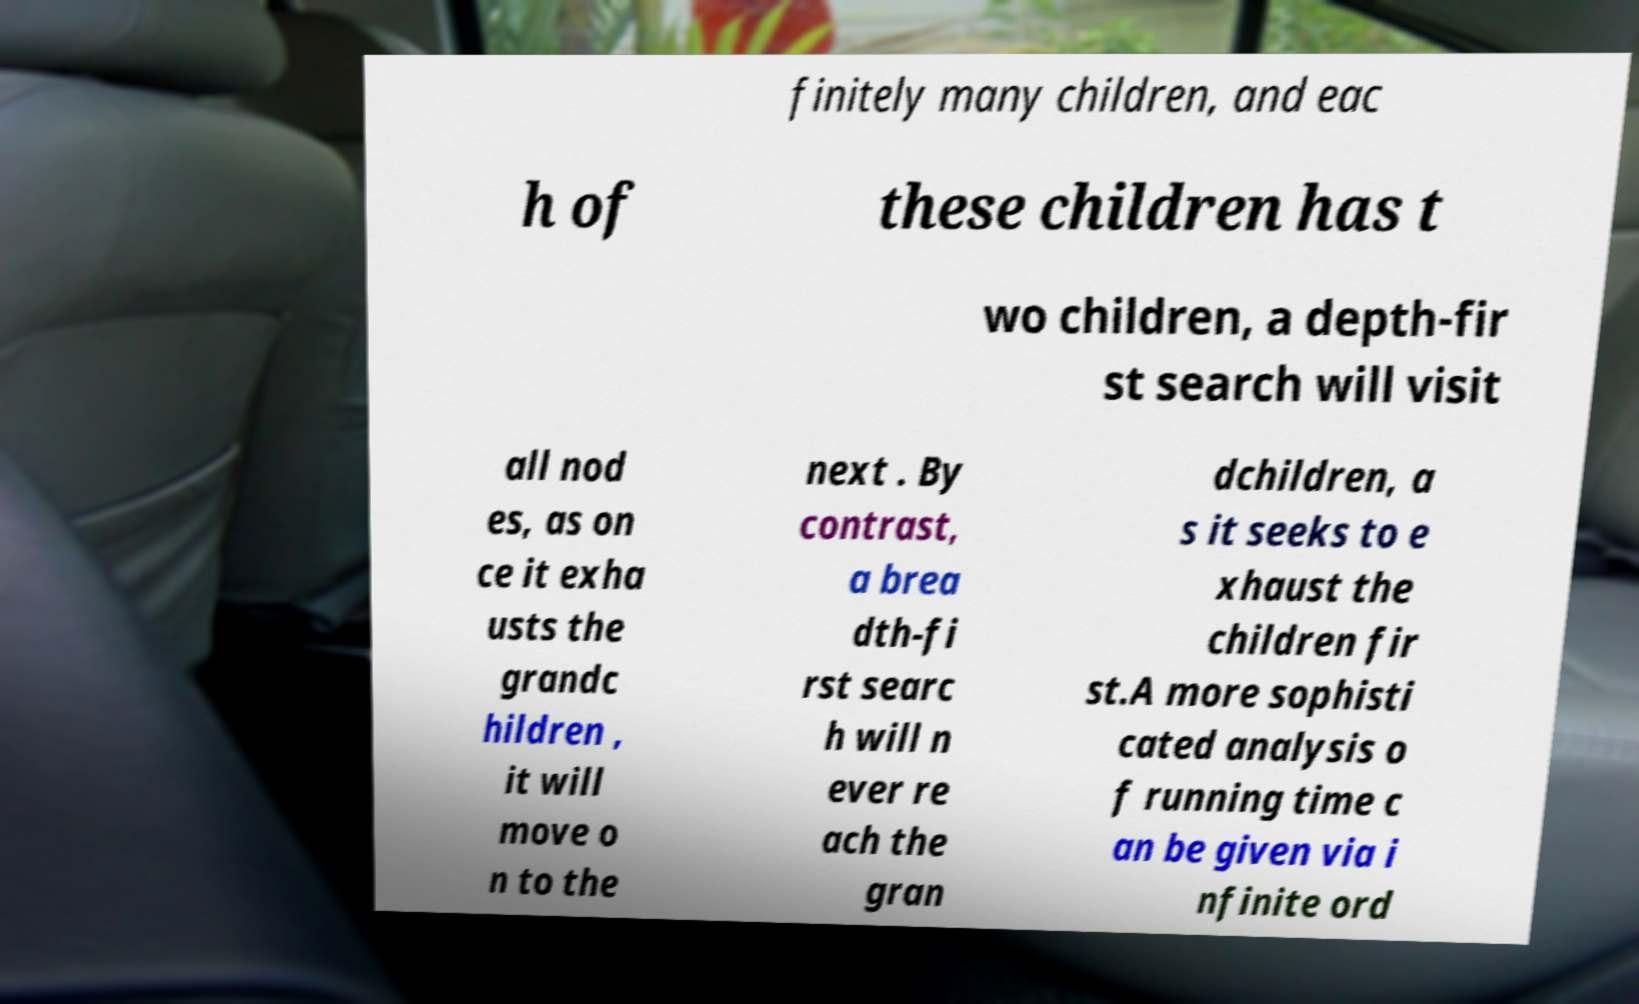I need the written content from this picture converted into text. Can you do that? finitely many children, and eac h of these children has t wo children, a depth-fir st search will visit all nod es, as on ce it exha usts the grandc hildren , it will move o n to the next . By contrast, a brea dth-fi rst searc h will n ever re ach the gran dchildren, a s it seeks to e xhaust the children fir st.A more sophisti cated analysis o f running time c an be given via i nfinite ord 